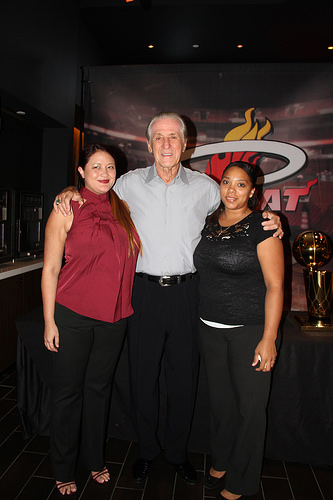<image>
Can you confirm if the woman is to the left of the man? No. The woman is not to the left of the man. From this viewpoint, they have a different horizontal relationship. Where is the woman in relation to the man? Is it behind the man? No. The woman is not behind the man. From this viewpoint, the woman appears to be positioned elsewhere in the scene. 